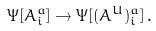Convert formula to latex. <formula><loc_0><loc_0><loc_500><loc_500>\Psi [ A _ { i } ^ { a } ] \rightarrow \Psi [ ( A ^ { U } ) _ { i } ^ { a } ] \, .</formula> 